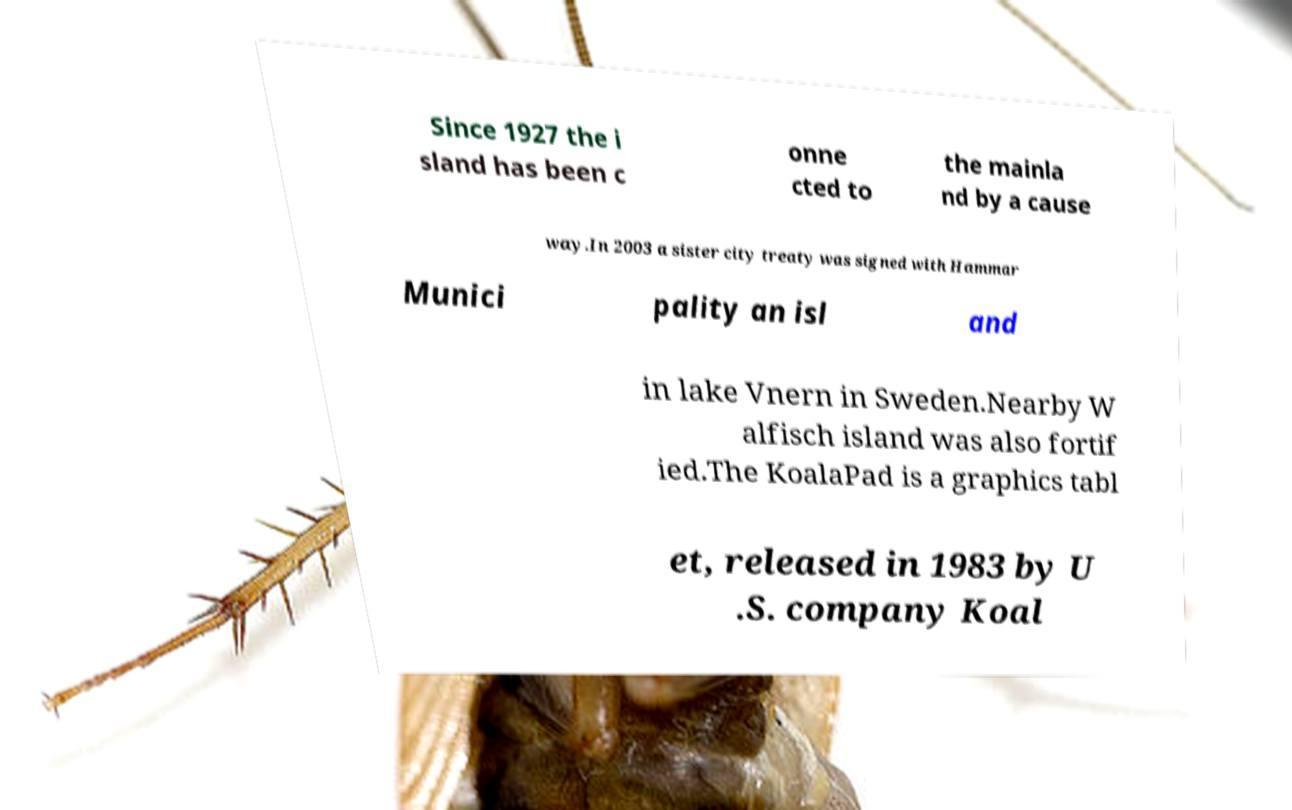Please read and relay the text visible in this image. What does it say? Since 1927 the i sland has been c onne cted to the mainla nd by a cause way.In 2003 a sister city treaty was signed with Hammar Munici pality an isl and in lake Vnern in Sweden.Nearby W alfisch island was also fortif ied.The KoalaPad is a graphics tabl et, released in 1983 by U .S. company Koal 